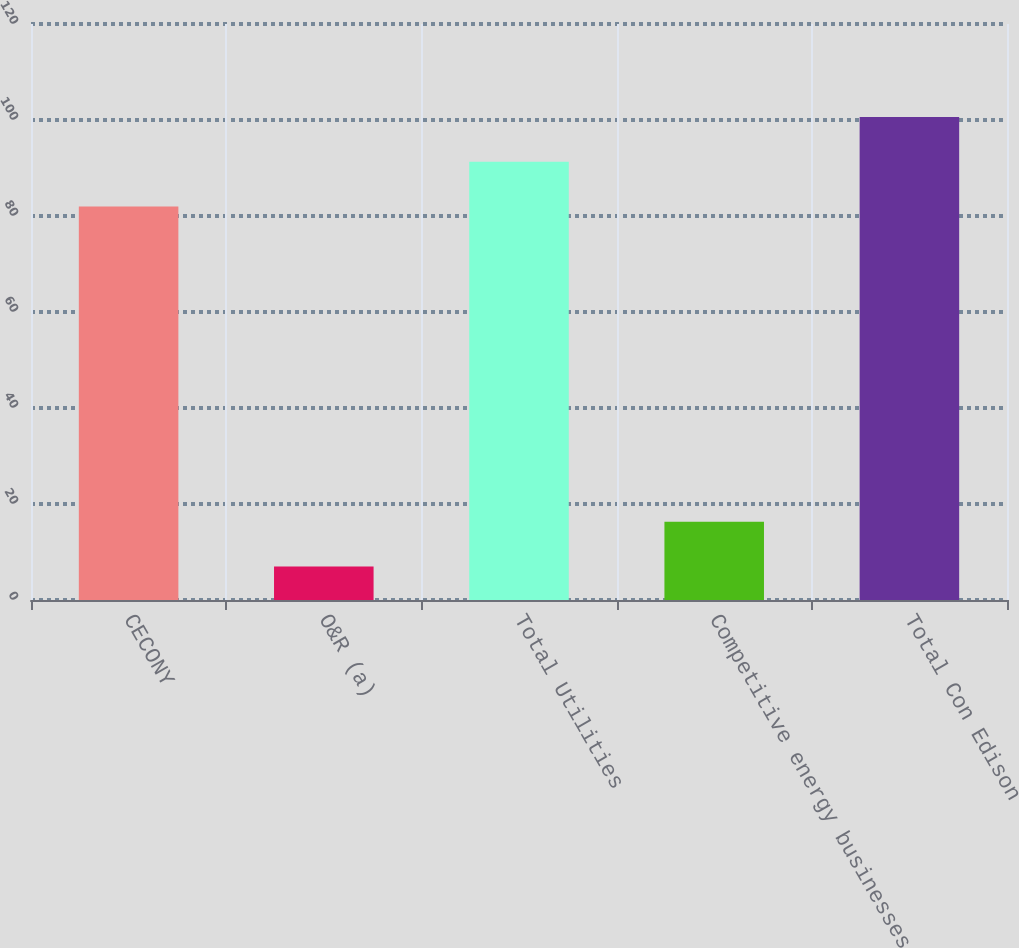Convert chart. <chart><loc_0><loc_0><loc_500><loc_500><bar_chart><fcel>CECONY<fcel>O&R (a)<fcel>Total Utilities<fcel>Competitive energy businesses<fcel>Total Con Edison<nl><fcel>82<fcel>7<fcel>91.3<fcel>16.3<fcel>100.6<nl></chart> 